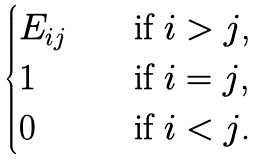Convert formula to latex. <formula><loc_0><loc_0><loc_500><loc_500>\begin{cases} E _ { i j } \quad & \text {if $i > j$,} \\ 1 \quad & \text {if $i = j$,} \\ 0 \quad & \text {if $i < j$.} \\ \end{cases}</formula> 